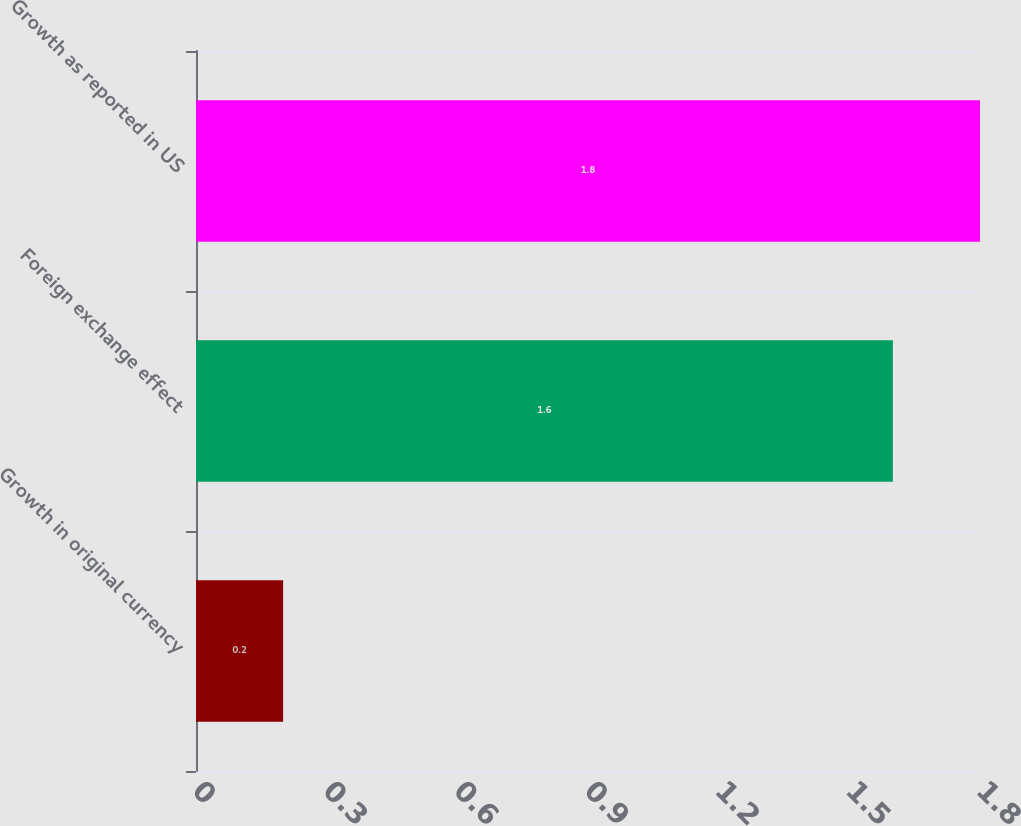Convert chart to OTSL. <chart><loc_0><loc_0><loc_500><loc_500><bar_chart><fcel>Growth in original currency<fcel>Foreign exchange effect<fcel>Growth as reported in US<nl><fcel>0.2<fcel>1.6<fcel>1.8<nl></chart> 